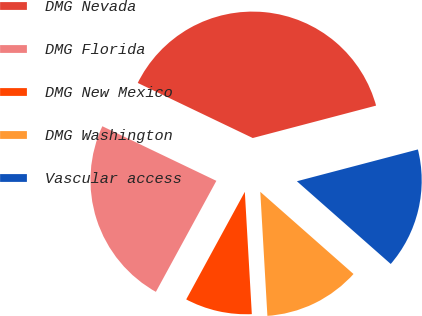<chart> <loc_0><loc_0><loc_500><loc_500><pie_chart><fcel>DMG Nevada<fcel>DMG Florida<fcel>DMG New Mexico<fcel>DMG Washington<fcel>Vascular access<nl><fcel>38.8%<fcel>24.17%<fcel>8.85%<fcel>12.59%<fcel>15.59%<nl></chart> 